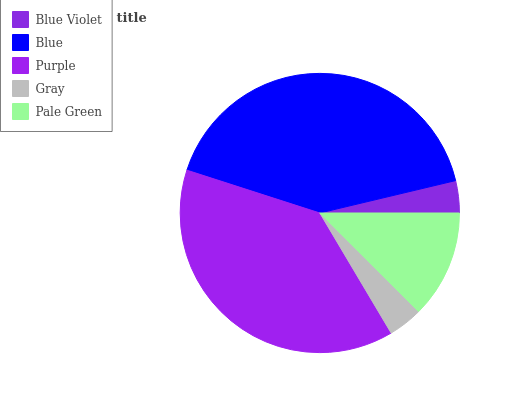Is Blue Violet the minimum?
Answer yes or no. Yes. Is Blue the maximum?
Answer yes or no. Yes. Is Purple the minimum?
Answer yes or no. No. Is Purple the maximum?
Answer yes or no. No. Is Blue greater than Purple?
Answer yes or no. Yes. Is Purple less than Blue?
Answer yes or no. Yes. Is Purple greater than Blue?
Answer yes or no. No. Is Blue less than Purple?
Answer yes or no. No. Is Pale Green the high median?
Answer yes or no. Yes. Is Pale Green the low median?
Answer yes or no. Yes. Is Gray the high median?
Answer yes or no. No. Is Blue Violet the low median?
Answer yes or no. No. 